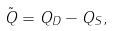<formula> <loc_0><loc_0><loc_500><loc_500>\tilde { Q } = Q _ { D } - Q _ { S } ,</formula> 